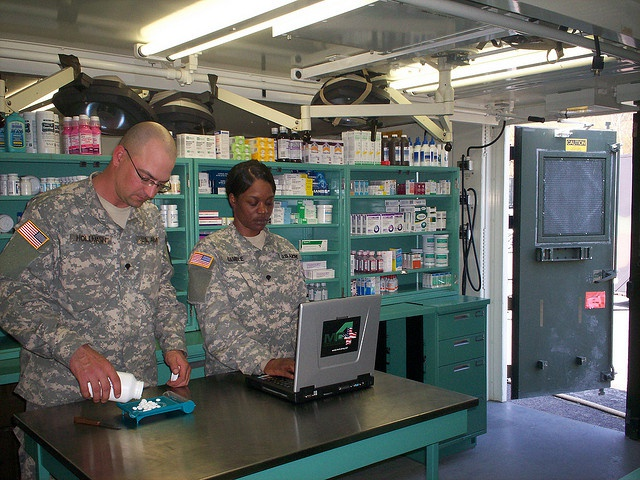Describe the objects in this image and their specific colors. I can see people in black, gray, brown, and darkgray tones, people in black, gray, darkgray, and maroon tones, laptop in black, gray, maroon, and darkgray tones, bottle in black, lightgray, darkgray, gray, and lightblue tones, and bottle in black, gray, darkgray, and teal tones in this image. 